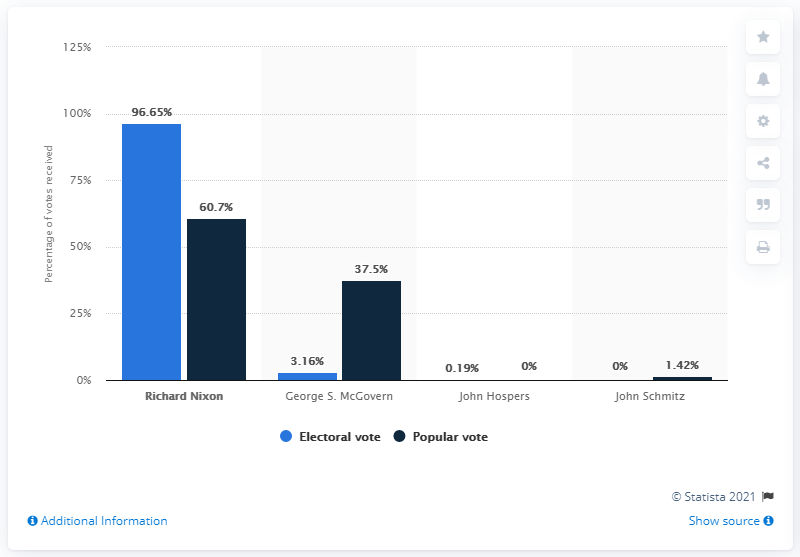Give some essential details in this illustration. The highest percentage in the blue chart is 96.65%. John Hospers was the only major third party candidate in United States history. George S. McGovern was the winner of the 1972 US presidential election. The sum of the first and last bar in the chart is 98.07. 